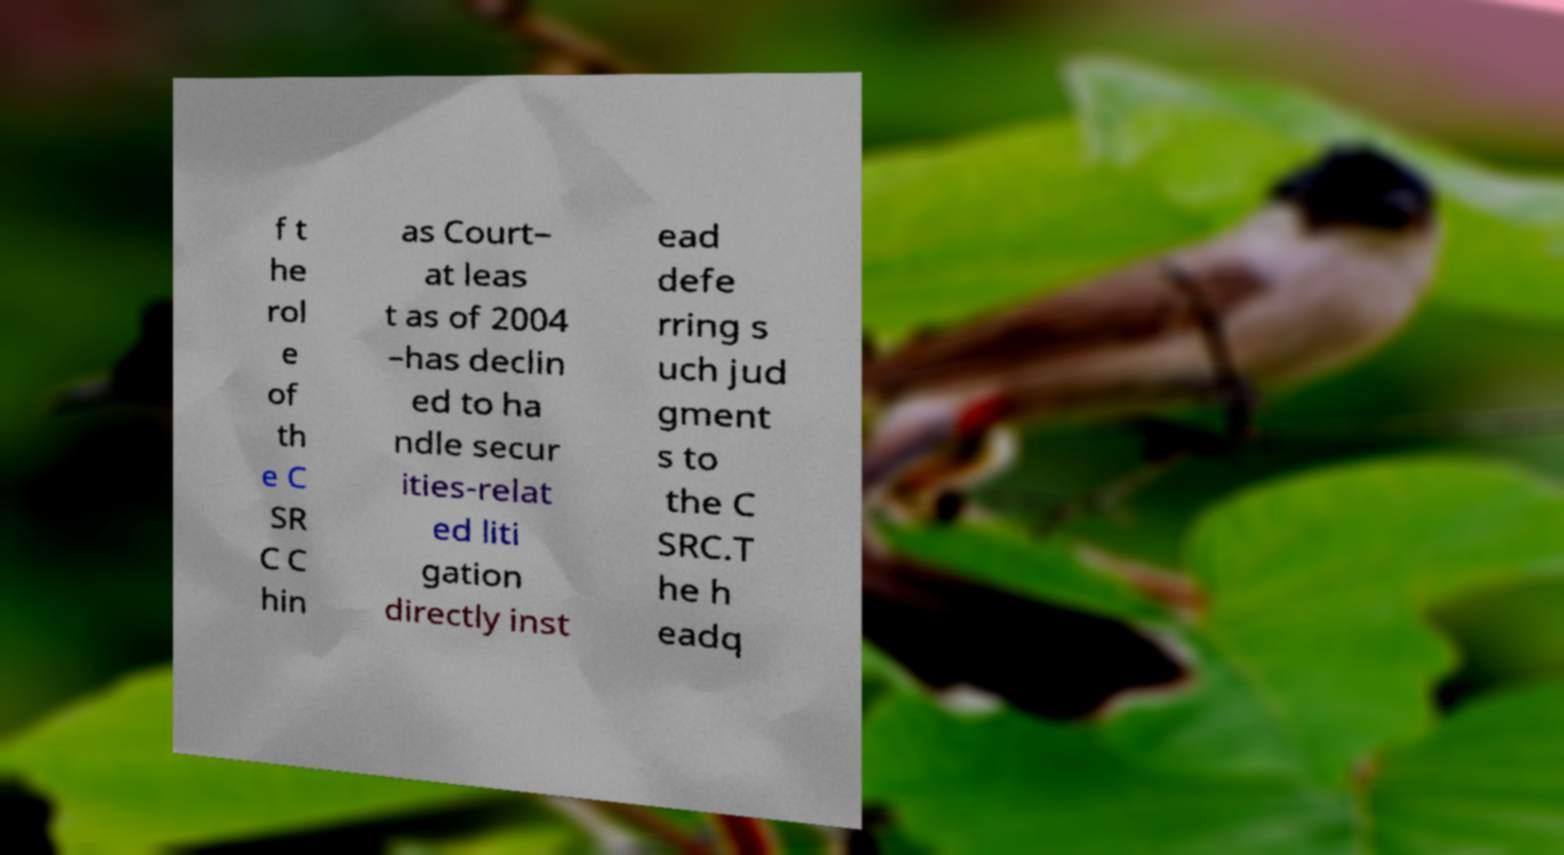There's text embedded in this image that I need extracted. Can you transcribe it verbatim? f t he rol e of th e C SR C C hin as Court– at leas t as of 2004 –has declin ed to ha ndle secur ities-relat ed liti gation directly inst ead defe rring s uch jud gment s to the C SRC.T he h eadq 